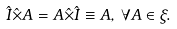<formula> <loc_0><loc_0><loc_500><loc_500>\hat { I } \hat { \times } A = A \hat { \times } \hat { I } \equiv A , \, \forall A \in \xi .</formula> 